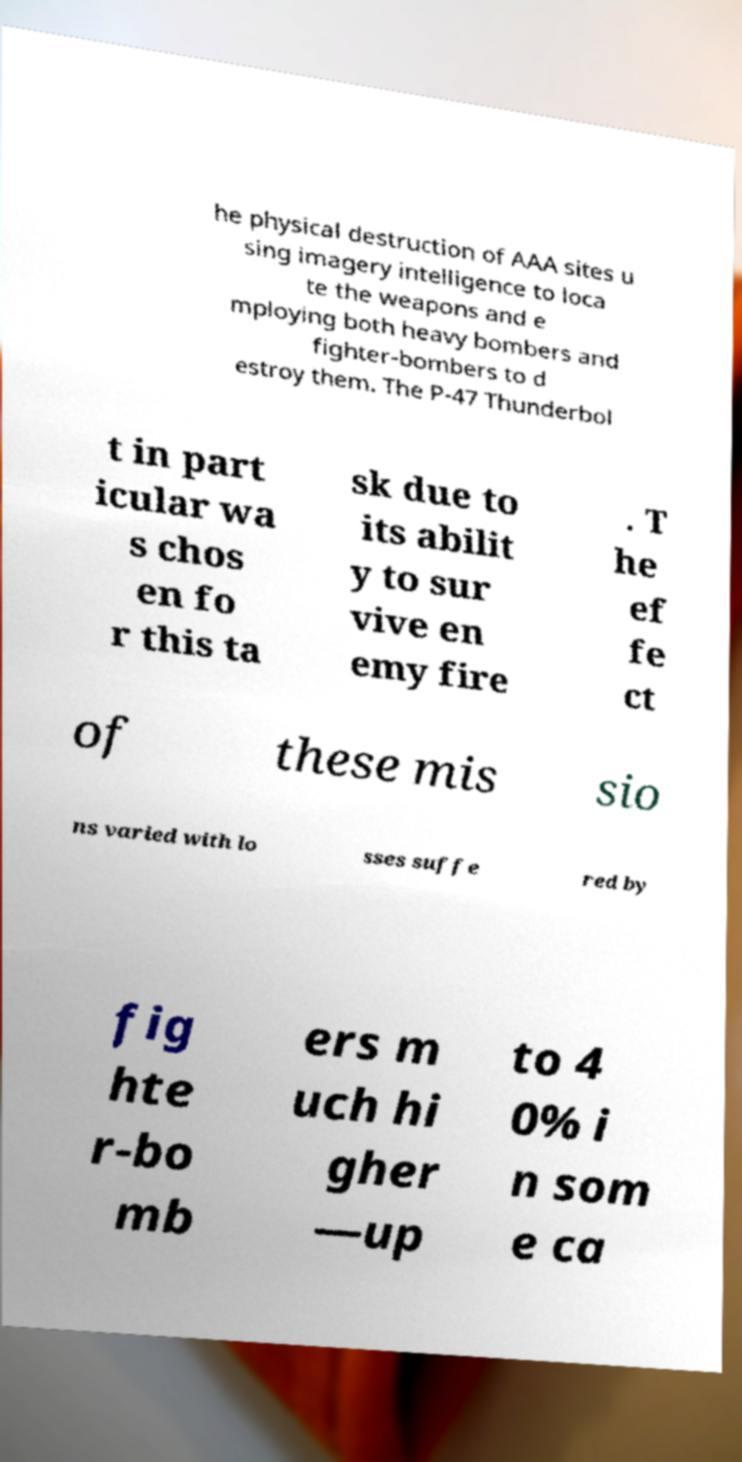What messages or text are displayed in this image? I need them in a readable, typed format. he physical destruction of AAA sites u sing imagery intelligence to loca te the weapons and e mploying both heavy bombers and fighter-bombers to d estroy them. The P-47 Thunderbol t in part icular wa s chos en fo r this ta sk due to its abilit y to sur vive en emy fire . T he ef fe ct of these mis sio ns varied with lo sses suffe red by fig hte r-bo mb ers m uch hi gher —up to 4 0% i n som e ca 